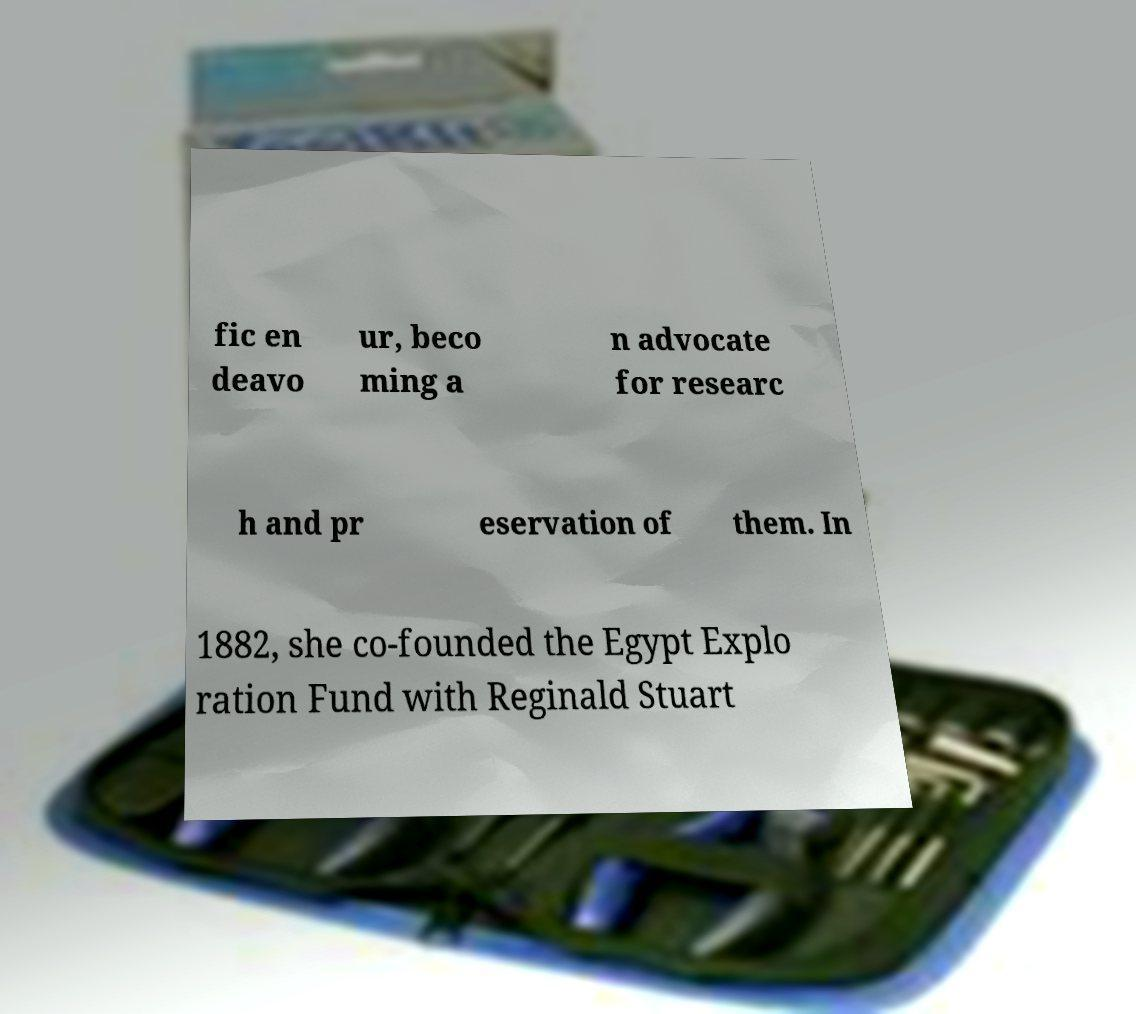Please read and relay the text visible in this image. What does it say? fic en deavo ur, beco ming a n advocate for researc h and pr eservation of them. In 1882, she co-founded the Egypt Explo ration Fund with Reginald Stuart 